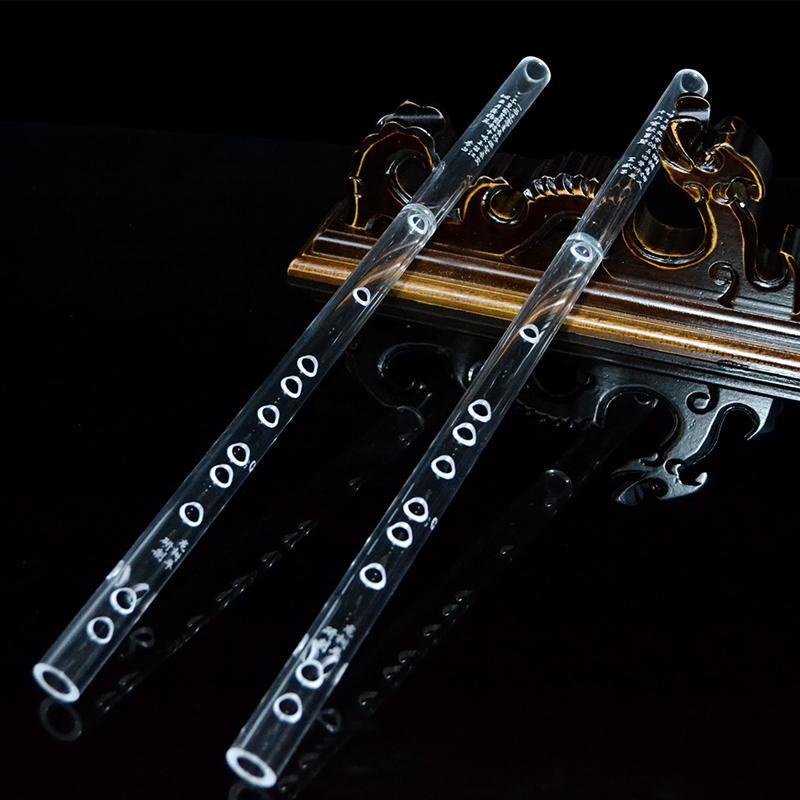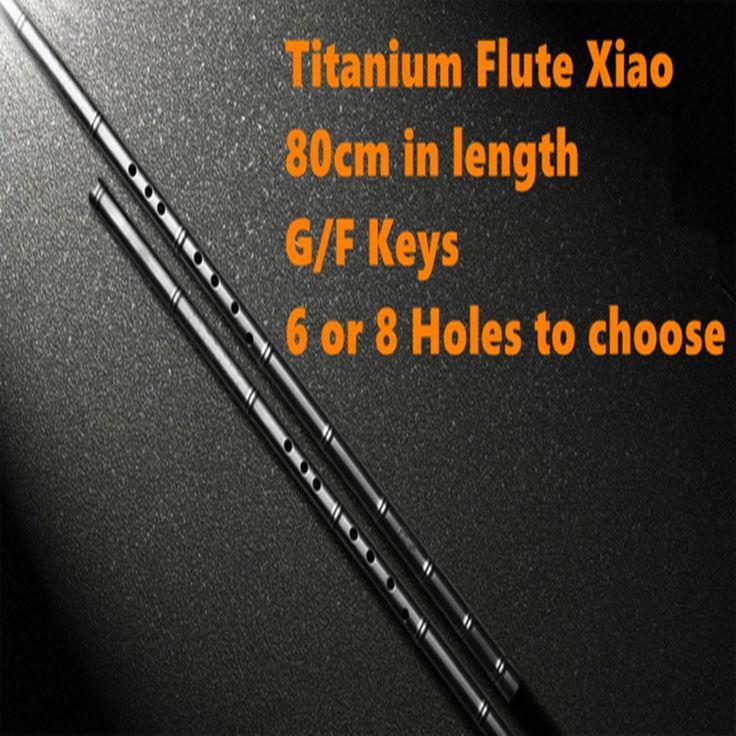The first image is the image on the left, the second image is the image on the right. For the images shown, is this caption "The right image contains exactly one flute like musical instrument." true? Answer yes or no. No. The first image is the image on the left, the second image is the image on the right. Given the left and right images, does the statement "The left and right image contains a total of two flutes." hold true? Answer yes or no. No. 